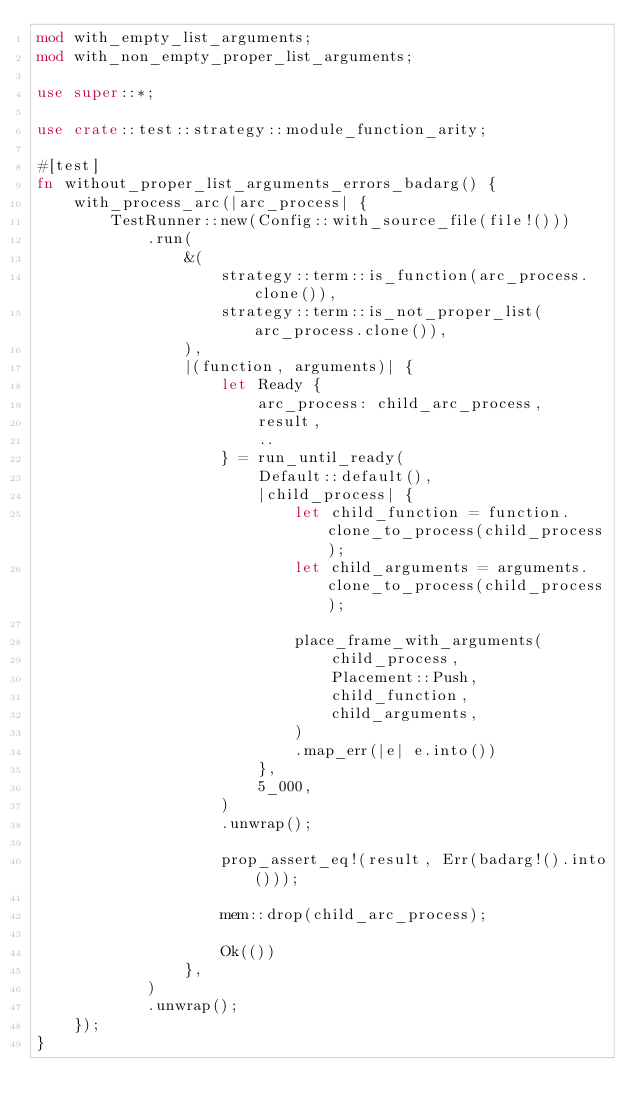Convert code to text. <code><loc_0><loc_0><loc_500><loc_500><_Rust_>mod with_empty_list_arguments;
mod with_non_empty_proper_list_arguments;

use super::*;

use crate::test::strategy::module_function_arity;

#[test]
fn without_proper_list_arguments_errors_badarg() {
    with_process_arc(|arc_process| {
        TestRunner::new(Config::with_source_file(file!()))
            .run(
                &(
                    strategy::term::is_function(arc_process.clone()),
                    strategy::term::is_not_proper_list(arc_process.clone()),
                ),
                |(function, arguments)| {
                    let Ready {
                        arc_process: child_arc_process,
                        result,
                        ..
                    } = run_until_ready(
                        Default::default(),
                        |child_process| {
                            let child_function = function.clone_to_process(child_process);
                            let child_arguments = arguments.clone_to_process(child_process);

                            place_frame_with_arguments(
                                child_process,
                                Placement::Push,
                                child_function,
                                child_arguments,
                            )
                            .map_err(|e| e.into())
                        },
                        5_000,
                    )
                    .unwrap();

                    prop_assert_eq!(result, Err(badarg!().into()));

                    mem::drop(child_arc_process);

                    Ok(())
                },
            )
            .unwrap();
    });
}
</code> 